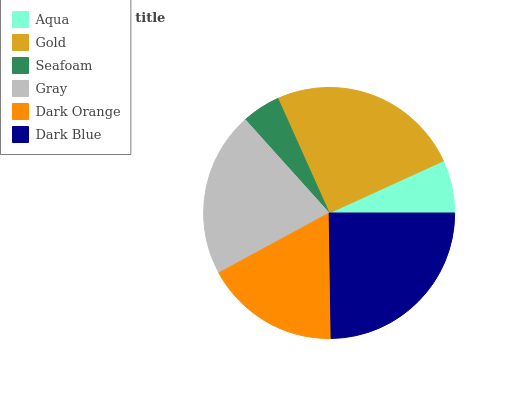Is Seafoam the minimum?
Answer yes or no. Yes. Is Gold the maximum?
Answer yes or no. Yes. Is Gold the minimum?
Answer yes or no. No. Is Seafoam the maximum?
Answer yes or no. No. Is Gold greater than Seafoam?
Answer yes or no. Yes. Is Seafoam less than Gold?
Answer yes or no. Yes. Is Seafoam greater than Gold?
Answer yes or no. No. Is Gold less than Seafoam?
Answer yes or no. No. Is Gray the high median?
Answer yes or no. Yes. Is Dark Orange the low median?
Answer yes or no. Yes. Is Dark Blue the high median?
Answer yes or no. No. Is Aqua the low median?
Answer yes or no. No. 